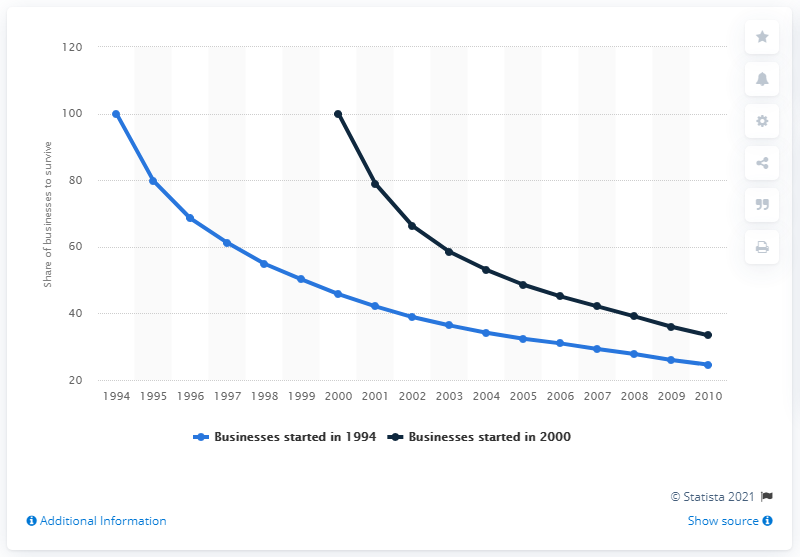List a handful of essential elements in this visual. Approximately 24.6% of businesses that were started in 1994 were still operating by 2010. 